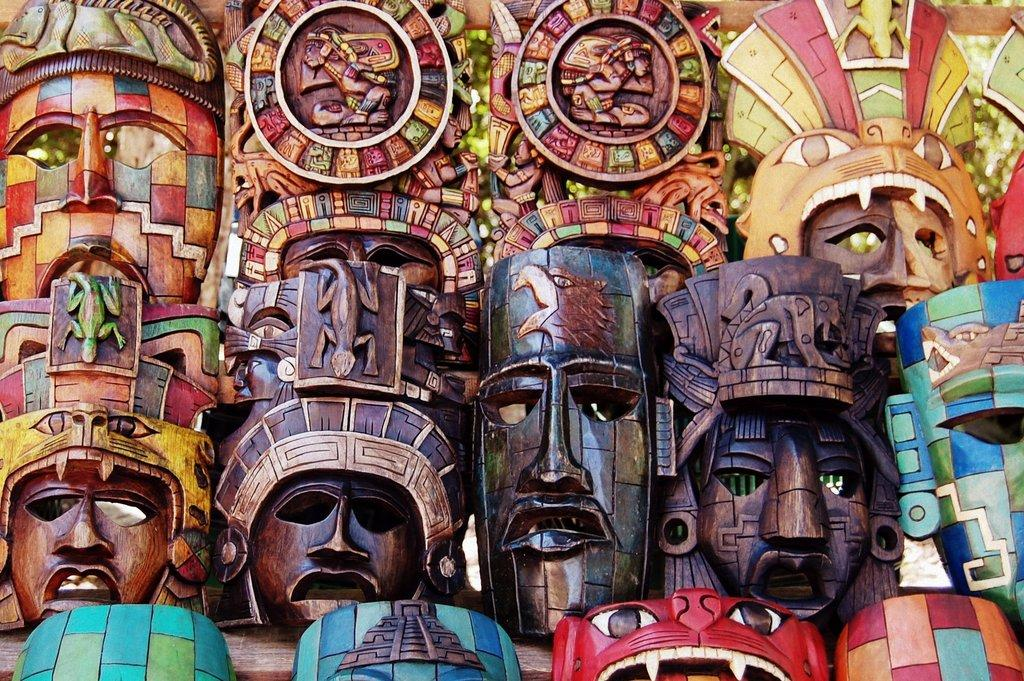What type of objects are featured in the image? There are wooden masks in the image. Can you describe the background of the image? The background of the image is blurry. What type of truck can be seen driving through the town in the image? There is no truck or town present in the image; it features wooden masks and a blurry background. 